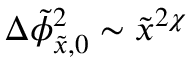Convert formula to latex. <formula><loc_0><loc_0><loc_500><loc_500>\Delta \tilde { \phi } _ { \tilde { x } , 0 } ^ { 2 } \sim \tilde { x } ^ { 2 \chi }</formula> 